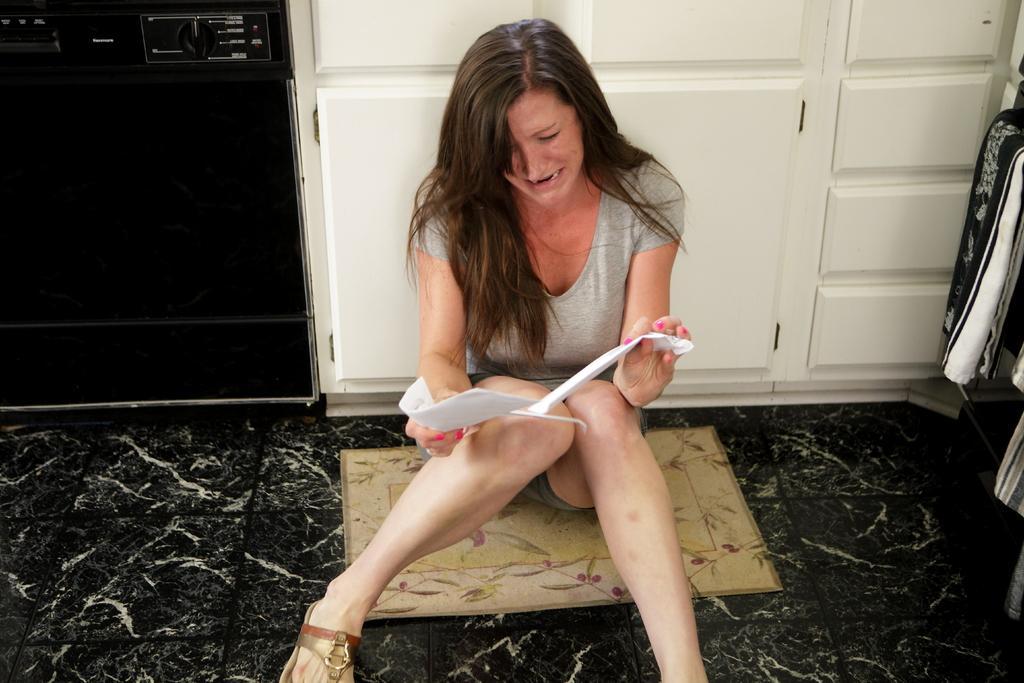Describe this image in one or two sentences. In this image we can see a woman is holding something in her hands and sitting on the doormat which is placed on the floor. In the background, we can see white color cupboards, towel and a black color machine here. 